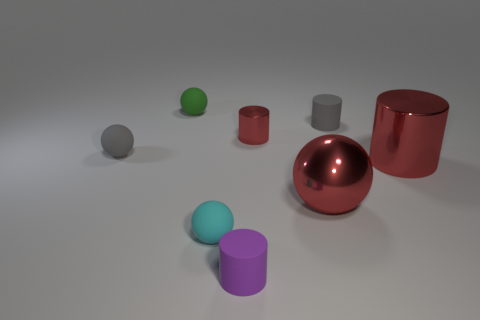Add 1 small cyan spheres. How many objects exist? 9 Subtract all gray rubber balls. How many balls are left? 3 Add 8 tiny gray rubber spheres. How many tiny gray rubber spheres are left? 9 Add 5 rubber things. How many rubber things exist? 10 Subtract all purple cylinders. How many cylinders are left? 3 Subtract 0 cyan cylinders. How many objects are left? 8 Subtract 1 cylinders. How many cylinders are left? 3 Subtract all brown balls. Subtract all yellow cylinders. How many balls are left? 4 Subtract all gray cylinders. How many brown balls are left? 0 Subtract all small cyan objects. Subtract all gray objects. How many objects are left? 5 